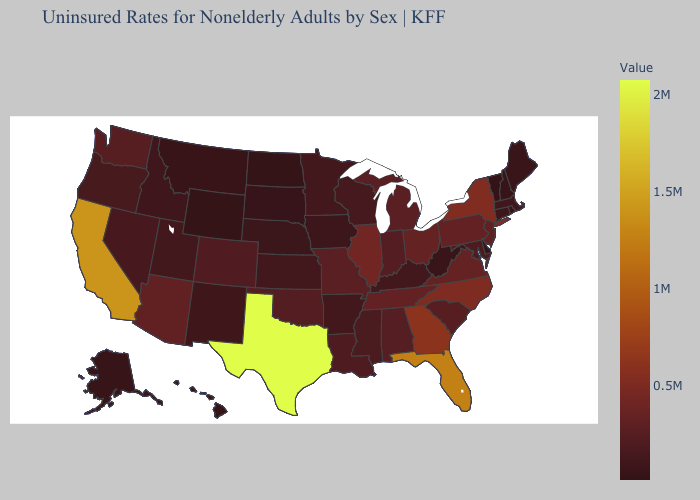Does Wisconsin have the highest value in the USA?
Write a very short answer. No. Which states have the highest value in the USA?
Short answer required. Texas. Does Florida have the lowest value in the USA?
Answer briefly. No. Among the states that border Oklahoma , which have the lowest value?
Give a very brief answer. New Mexico. Among the states that border Connecticut , does New York have the highest value?
Short answer required. Yes. Is the legend a continuous bar?
Quick response, please. Yes. 